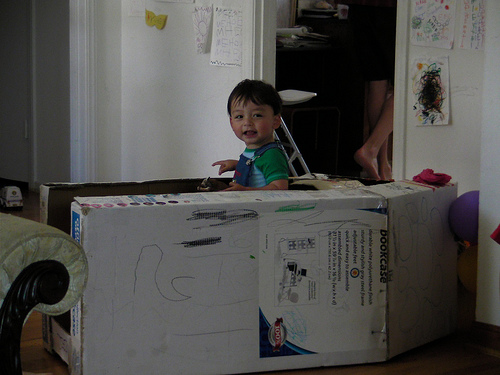<image>
Can you confirm if the boy is in front of the box? No. The boy is not in front of the box. The spatial positioning shows a different relationship between these objects. 